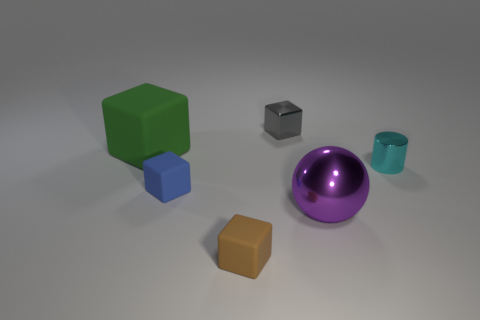Are there fewer small rubber blocks than green matte blocks?
Offer a terse response. No. The metallic object that is in front of the blue matte block that is to the left of the tiny shiny object right of the gray thing is what shape?
Provide a short and direct response. Sphere. Are there any gray balls that have the same material as the big purple object?
Give a very brief answer. No. Are there fewer small blue rubber objects on the right side of the blue rubber cube than purple cylinders?
Your answer should be very brief. No. What number of things are either purple metal objects or objects that are behind the big rubber cube?
Make the answer very short. 2. What color is the big cube that is the same material as the small blue object?
Your answer should be compact. Green. What number of things are either cyan metallic cylinders or tiny yellow blocks?
Offer a very short reply. 1. There is a metallic cube that is the same size as the cyan shiny thing; what is its color?
Provide a succinct answer. Gray. What number of objects are small blocks that are in front of the large green cube or big metallic objects?
Offer a very short reply. 3. How many other objects are there of the same size as the sphere?
Offer a very short reply. 1. 